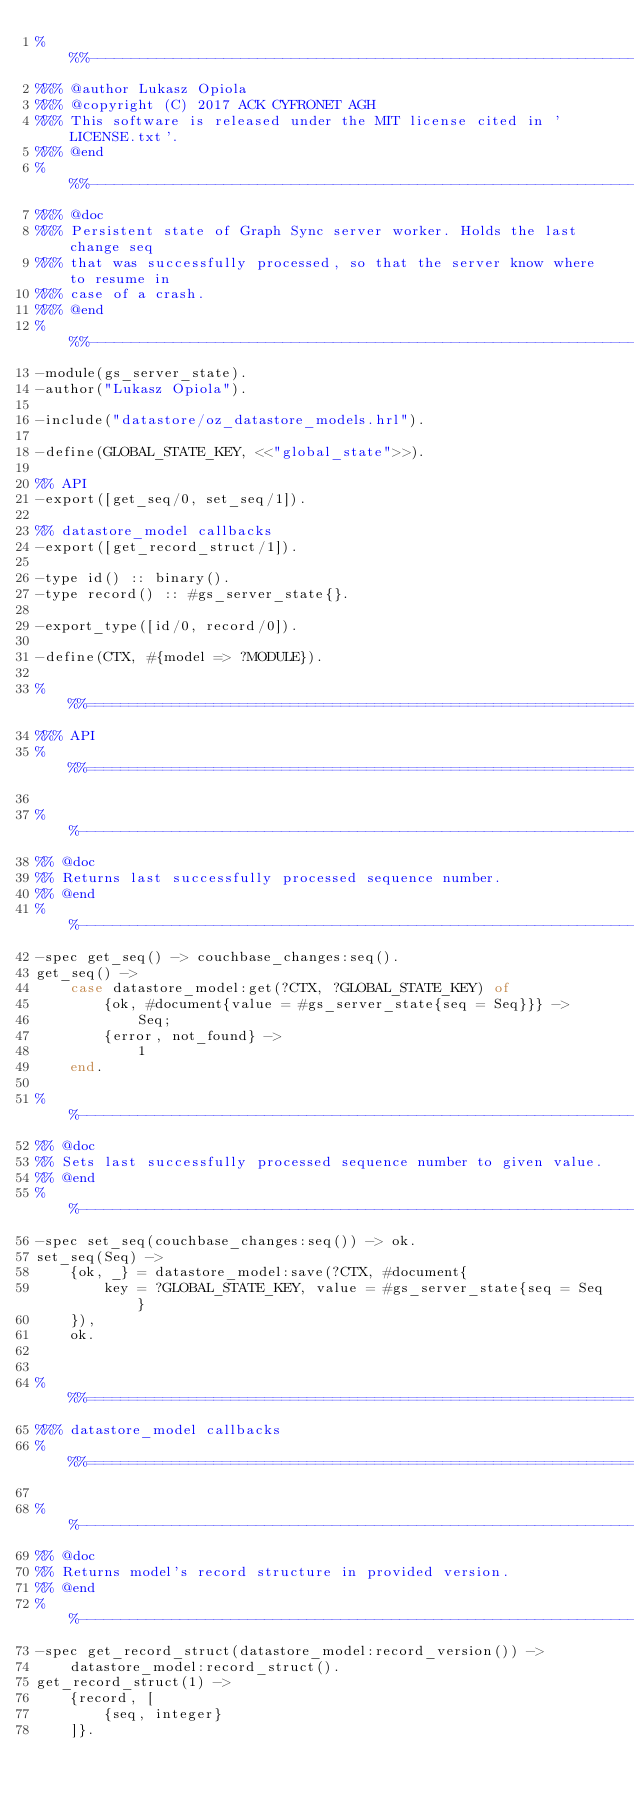<code> <loc_0><loc_0><loc_500><loc_500><_Erlang_>%%%-------------------------------------------------------------------
%%% @author Lukasz Opiola
%%% @copyright (C) 2017 ACK CYFRONET AGH
%%% This software is released under the MIT license cited in 'LICENSE.txt'.
%%% @end
%%%-------------------------------------------------------------------
%%% @doc
%%% Persistent state of Graph Sync server worker. Holds the last change seq
%%% that was successfully processed, so that the server know where to resume in
%%% case of a crash.
%%% @end
%%%-------------------------------------------------------------------
-module(gs_server_state).
-author("Lukasz Opiola").

-include("datastore/oz_datastore_models.hrl").

-define(GLOBAL_STATE_KEY, <<"global_state">>).

%% API
-export([get_seq/0, set_seq/1]).

%% datastore_model callbacks
-export([get_record_struct/1]).

-type id() :: binary().
-type record() :: #gs_server_state{}.

-export_type([id/0, record/0]).

-define(CTX, #{model => ?MODULE}).

%%%===================================================================
%%% API
%%%===================================================================

%%--------------------------------------------------------------------
%% @doc
%% Returns last successfully processed sequence number.
%% @end
%%--------------------------------------------------------------------
-spec get_seq() -> couchbase_changes:seq().
get_seq() ->
    case datastore_model:get(?CTX, ?GLOBAL_STATE_KEY) of
        {ok, #document{value = #gs_server_state{seq = Seq}}} ->
            Seq;
        {error, not_found} ->
            1
    end.

%%--------------------------------------------------------------------
%% @doc
%% Sets last successfully processed sequence number to given value.
%% @end
%%--------------------------------------------------------------------
-spec set_seq(couchbase_changes:seq()) -> ok.
set_seq(Seq) ->
    {ok, _} = datastore_model:save(?CTX, #document{
        key = ?GLOBAL_STATE_KEY, value = #gs_server_state{seq = Seq}
    }),
    ok.


%%%===================================================================
%%% datastore_model callbacks
%%%===================================================================

%%--------------------------------------------------------------------
%% @doc
%% Returns model's record structure in provided version.
%% @end
%%--------------------------------------------------------------------
-spec get_record_struct(datastore_model:record_version()) ->
    datastore_model:record_struct().
get_record_struct(1) ->
    {record, [
        {seq, integer}
    ]}.

</code> 